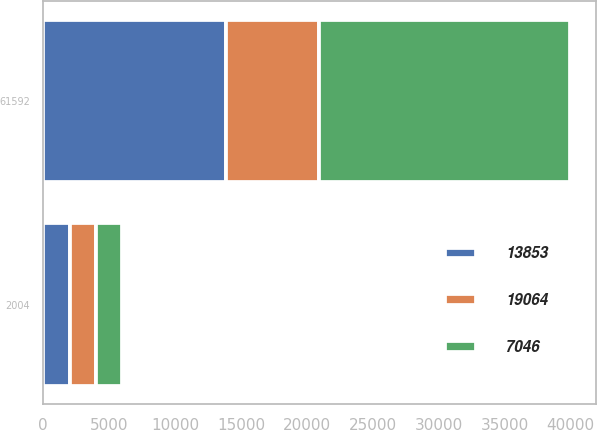Convert chart. <chart><loc_0><loc_0><loc_500><loc_500><stacked_bar_chart><ecel><fcel>2004<fcel>61592<nl><fcel>7046<fcel>2003<fcel>19064<nl><fcel>19064<fcel>2002<fcel>7046<nl><fcel>13853<fcel>2001<fcel>13853<nl></chart> 